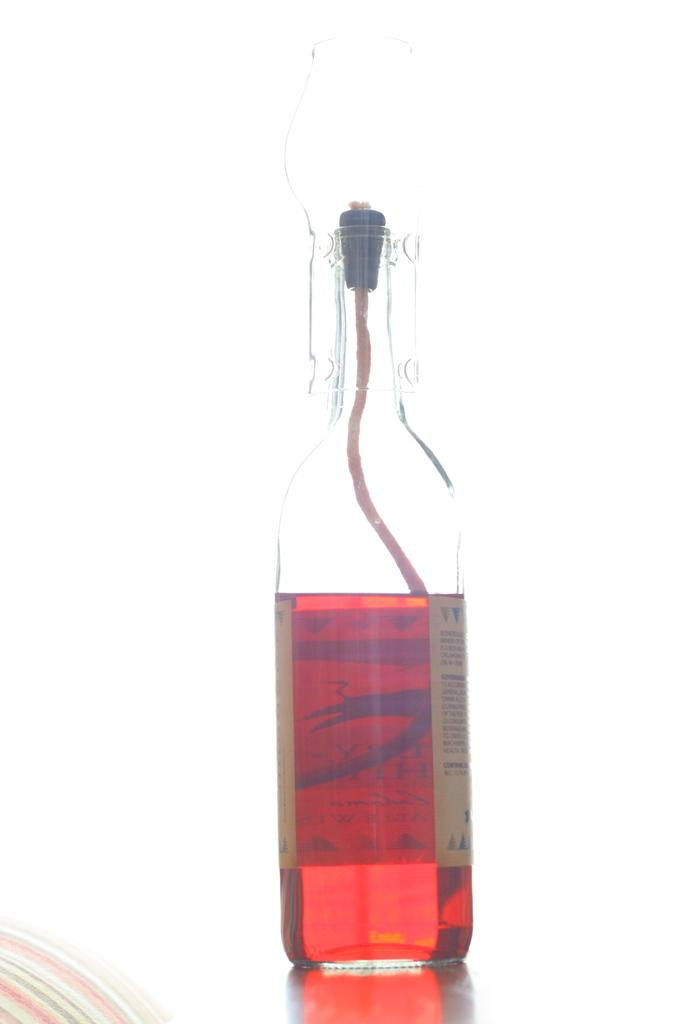What object can be seen in the image? There is a bottle in the image. What is inside the bottle? The bottle contains a red drink. What type of sofa is depicted in the image? There is no sofa present in the image; it only features a bottle containing a red drink. What kind of oil can be seen dripping from the bottle in the image? There is no oil present in the image; the bottle contains a red drink. 